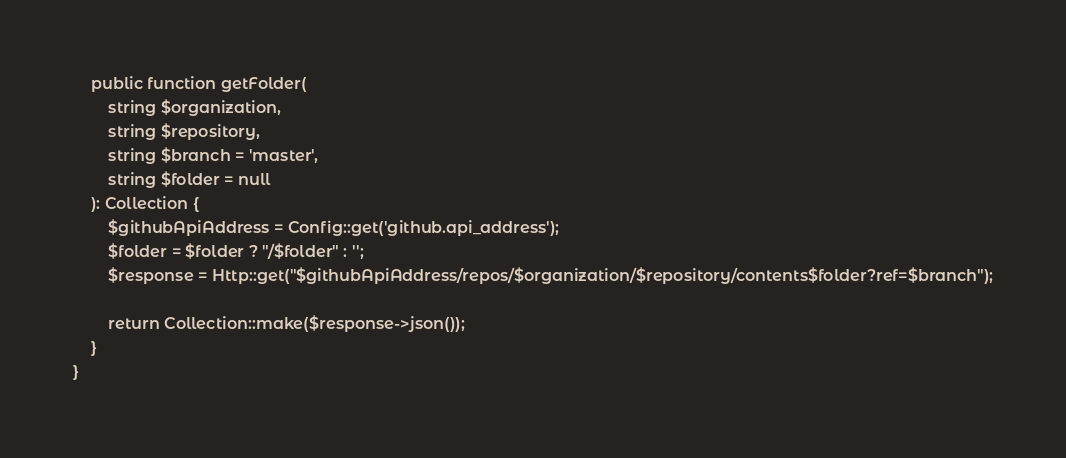Convert code to text. <code><loc_0><loc_0><loc_500><loc_500><_PHP_>    public function getFolder(
        string $organization,
        string $repository,
        string $branch = 'master',
        string $folder = null
    ): Collection {
        $githubApiAddress = Config::get('github.api_address');
        $folder = $folder ? "/$folder" : '';
        $response = Http::get("$githubApiAddress/repos/$organization/$repository/contents$folder?ref=$branch");

        return Collection::make($response->json());
    }
}</code> 